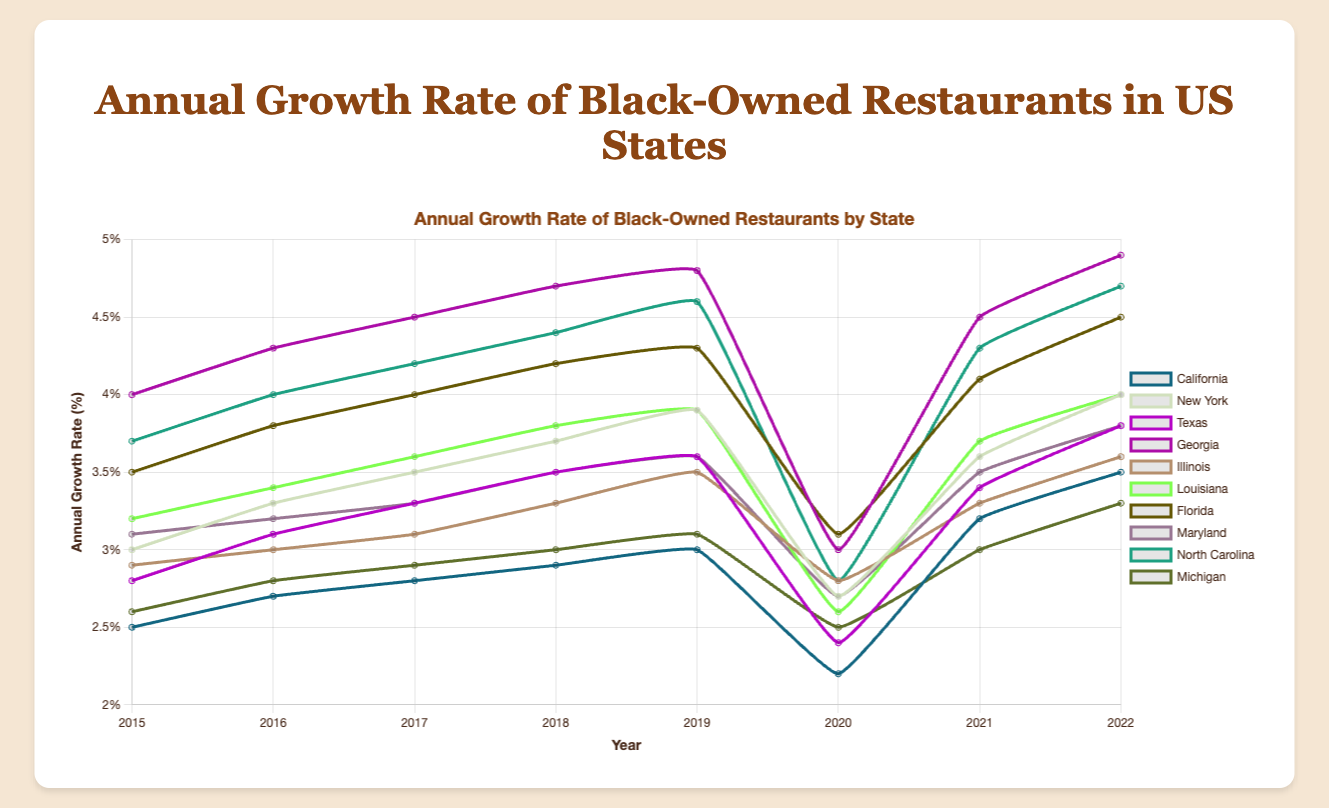Which state had the highest growth rate of Black-owned restaurants in 2022? To find this, look at the growth rate values for 2022 and identify the highest one. Georgia has the highest growth rate of 4.9%.
Answer: Georgia Which state experienced the biggest drop in the growth rate between 2019 and 2020? To determine this, compare the growth rates of each state between 2019 and 2020 and find which state has the largest decrease. California dropped from 3.0% to 2.2%, the largest decrease of 0.8%.
Answer: California What is the average annual growth rate of Black-owned restaurants in New York from 2015 to 2022? Sum all the annual growth rates for New York from 2015 to 2022 and divide by the number of years (8). The sum is 3.0 + 3.3 + 3.5 + 3.7 + 3.9 + 2.7 + 3.6 + 4.0 = 27.7, so the average is 27.7 / 8 = 3.4625%.
Answer: 3.4625% How did the growth rate of Black-owned restaurants in Georgia change from 2015 to 2022? Examine the growth rate for Georgia in 2015 and 2022. In 2015, it was 4.0%, and in 2022, it was 4.9%, increasing by 0.9%.
Answer: Increased by 0.9% Which year had the lowest average growth rate across all states? To find the lowest average growth rate, calculate the average for each year and compare them. The year 2020 had the lowest with an average of (2.2+2.7+2.4+3.0+2.8+2.6+3.1+2.7+2.8+2.5)/10 = 2.68%.
Answer: 2020 Did the growth rate of Black-owned restaurants in Florida ever exceed 4% before 2019? Look at Florida's growth rate from 2015 to 2018. It was 3.5% in 2015, 3.8% in 2016, 4.0% in 2017, and 4.2% in 2018. It exceeded 4% in 2018.
Answer: Yes Which state had a more steady growth rate: California or Michigan? Compare the annual growth rate fluctuations of California and Michigan. California varies between 2.2% and 3.5%, while Michigan varies between 2.5% and 3.3%. Michigan has less fluctuation.
Answer: Michigan What was the growth rate of Black-owned restaurants in Texas in 2020, and how does it compare to 2022? Check the growth rates for Texas in 2020 (2.4%) and 2022 (3.8%). It increased by 3.8 - 2.4 = 1.4%.
Answer: Increased by 1.4% Which state's growth rate had the sharpest increase from 2020 to 2021? Compare the growth rate increase from 2020 to 2021 for each state. California increased from 2.2% to 3.2%, a rise of 1.0%, which is the sharpest.
Answer: California Which state had the most consistent annual growth rate trend over the years 2015-2022? By visually examining each state’s line on the plot, Maryland's growth rate appears the most consistent, with minor fluctuations from 3.1% to 3.8%.
Answer: Maryland 